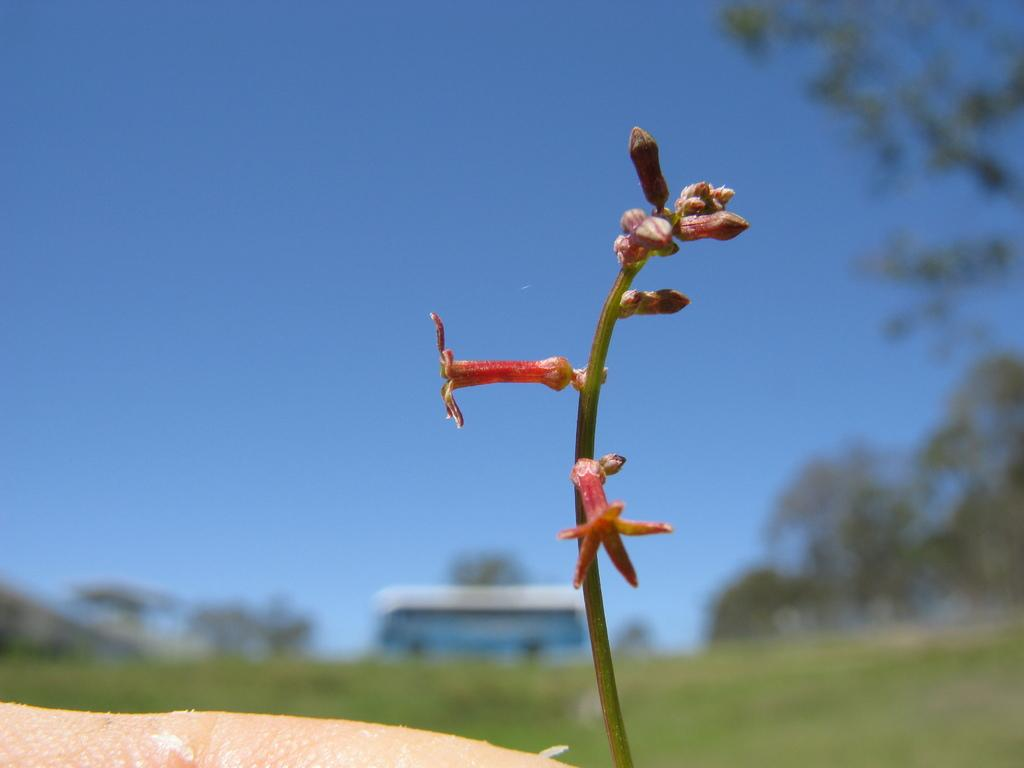What type of plant is on the right side of the image? There is a plant with flowers on the right side of the image. What is on the left side of the image? There is a skin on the left side of the image. What can be seen in the background of the image? There are trees and a building in the background of the image. What is the color of the sky in the background of the image? The sky in the background of the image is blue, and there are clouds visible. What type of advertisement is displayed on the skin in the image? There is no advertisement present on the skin in the image. What material is the nail made of in the image? There is no nail present in the image. 